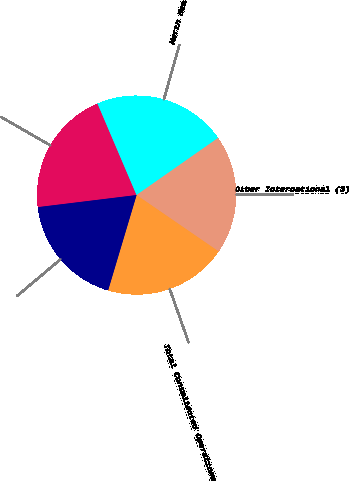<chart> <loc_0><loc_0><loc_500><loc_500><pie_chart><fcel>Equatorial Guinea (2)<fcel>North Sea<fcel>Other International (3)<fcel>Total Consolidated Operations<fcel>Equity Investee (4)<nl><fcel>20.52%<fcel>21.69%<fcel>19.31%<fcel>20.04%<fcel>18.44%<nl></chart> 